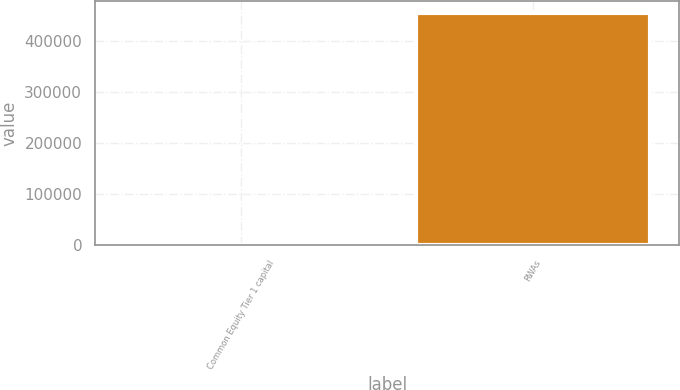Convert chart to OTSL. <chart><loc_0><loc_0><loc_500><loc_500><bar_chart><fcel>Common Equity Tier 1 capital<fcel>RWAs<nl><fcel>10.9<fcel>454968<nl></chart> 